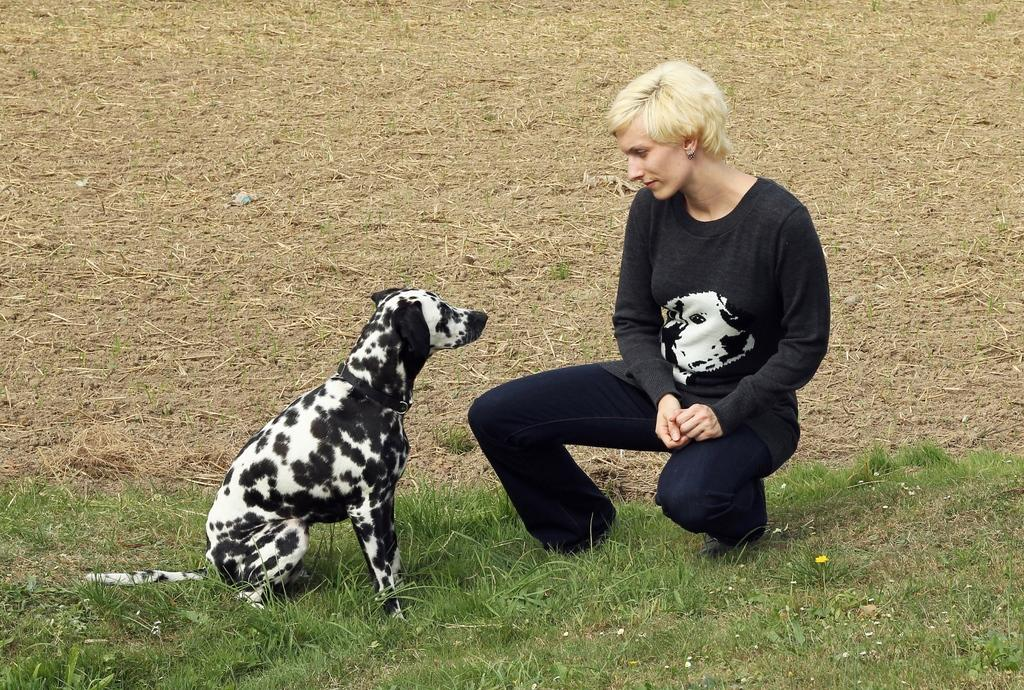What type of animal can be seen in the image? There is a dog in the image. What is the lady doing in the image? The lady is sitting in the image. What type of surface is at the bottom of the image? There is grass at the bottom of the image. Who is the manager of the dog in the image? There is no mention of a manager or any indication that the dog has a manager in the image. 